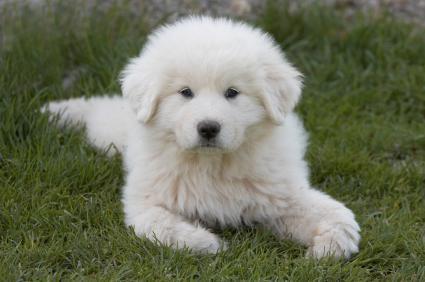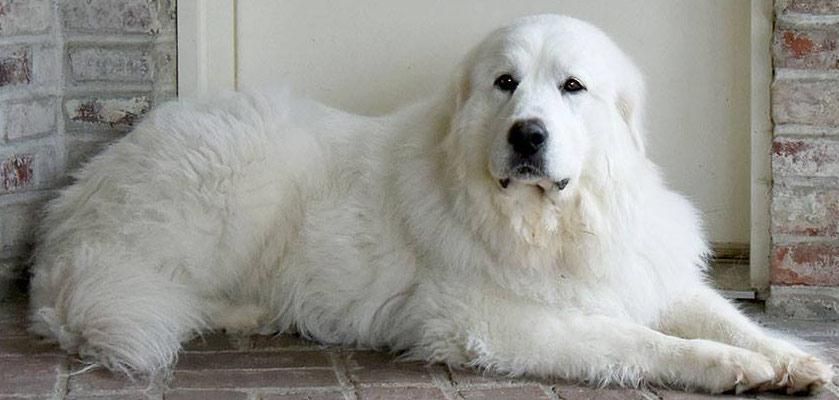The first image is the image on the left, the second image is the image on the right. Given the left and right images, does the statement "A large white dog, standing at an outdoor location, has its mouth open and is showing its tongue." hold true? Answer yes or no. No. The first image is the image on the left, the second image is the image on the right. Analyze the images presented: Is the assertion "The dog on the right is standing in the grass." valid? Answer yes or no. No. 